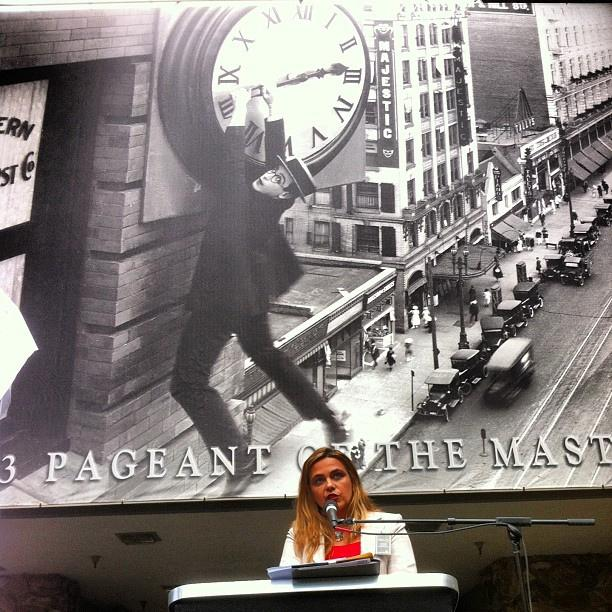What is this movie most likely to be? comedy 